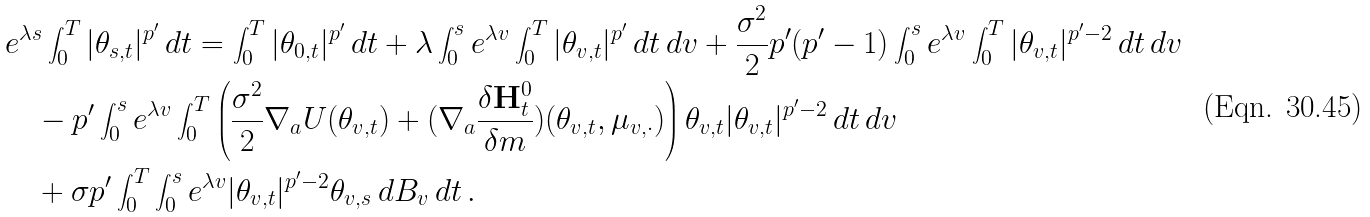<formula> <loc_0><loc_0><loc_500><loc_500>& e ^ { \lambda s } \int _ { 0 } ^ { T } | \theta _ { s , t } | ^ { p ^ { \prime } } \, d t = \int _ { 0 } ^ { T } | \theta _ { 0 , t } | ^ { p ^ { \prime } } \, d t + \lambda \int _ { 0 } ^ { s } e ^ { \lambda v } \int _ { 0 } ^ { T } | \theta _ { v , t } | ^ { p ^ { \prime } } \, d t \, d v + \frac { \sigma ^ { 2 } } 2 p ^ { \prime } ( p ^ { \prime } - 1 ) \int _ { 0 } ^ { s } e ^ { \lambda v } \int _ { 0 } ^ { T } | \theta _ { v , t } | ^ { p ^ { \prime } - 2 } \, d t \, d v \\ & \quad - p ^ { \prime } \int _ { 0 } ^ { s } e ^ { \lambda v } \int _ { 0 } ^ { T } \left ( \frac { \sigma ^ { 2 } } { 2 } \nabla _ { a } U ( \theta _ { v , t } ) + ( \nabla _ { a } \frac { \delta \mathbf H _ { t } ^ { 0 } } { \delta m } ) ( \theta _ { v , t } , \mu _ { v , \cdot } ) \right ) \theta _ { v , t } | \theta _ { v , t } | ^ { p ^ { \prime } - 2 } \, d t \, d v \\ & \quad + \sigma p ^ { \prime } \int _ { 0 } ^ { T } \int _ { 0 } ^ { s } e ^ { \lambda v } | \theta _ { v , t } | ^ { p ^ { \prime } - 2 } \theta _ { v , s } \, d B _ { v } \, d t \, . \\</formula> 